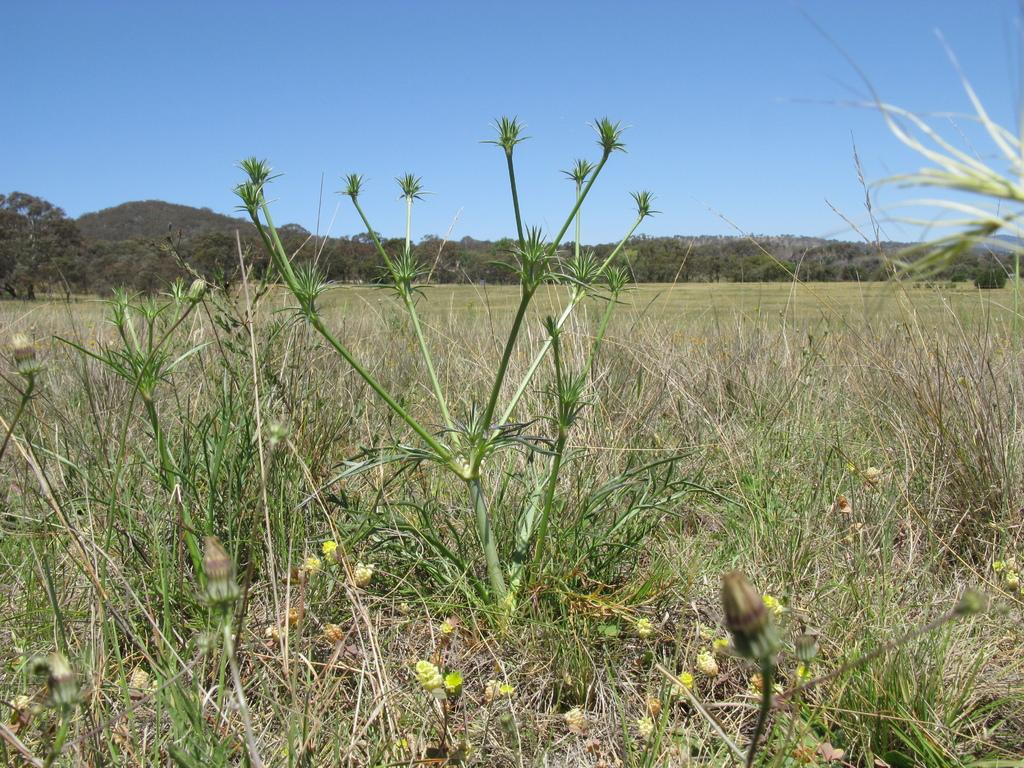What type of vegetation is in the front of the image? There are plants and grass in the front of the image. What can be seen in the background of the image? There are trees and the sky visible in the background of the image. How many eggs are being smashed by the trees in the background? There are no eggs present in the image, and the trees are not shown to be smashing anything. 